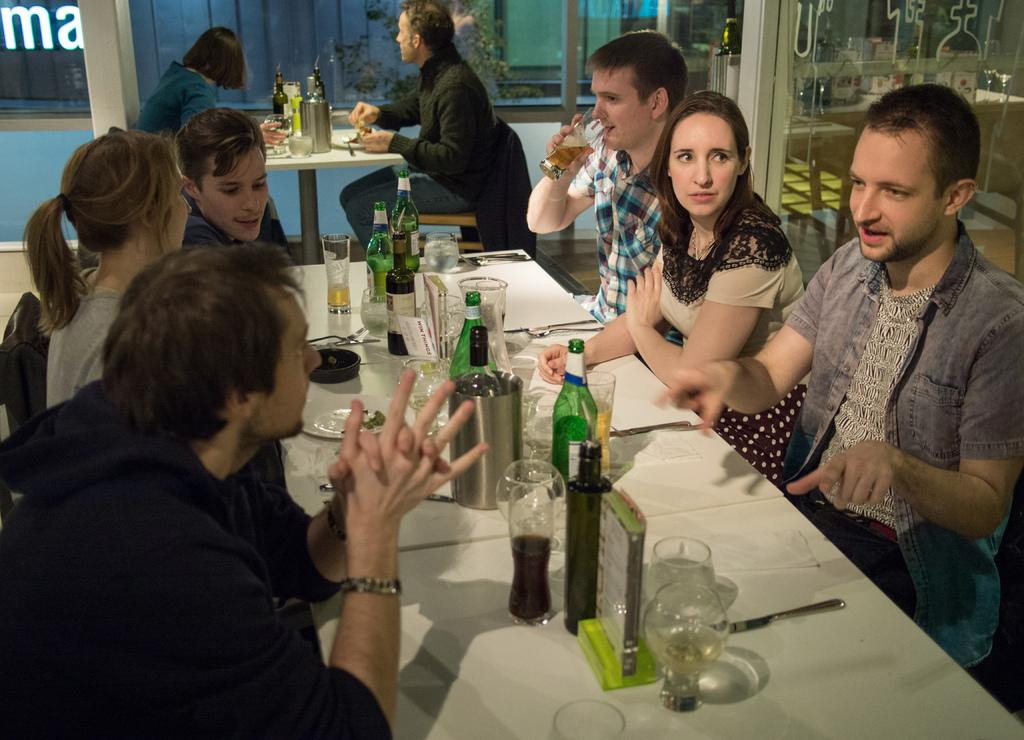How many people are in the image? There is a group of people in the image, but the exact number is not specified. What are the people doing in the image? The people are sitting on chairs in the image. What is the arrangement of the chairs in the image? The chairs are around a table in the image. What can be seen on the table in the image? There are water bottles, wine bottles, and glasses on the table in the image. What type of plastic material is used to make the cub in the image? There is no mention of a cub or any plastic material in the image. 